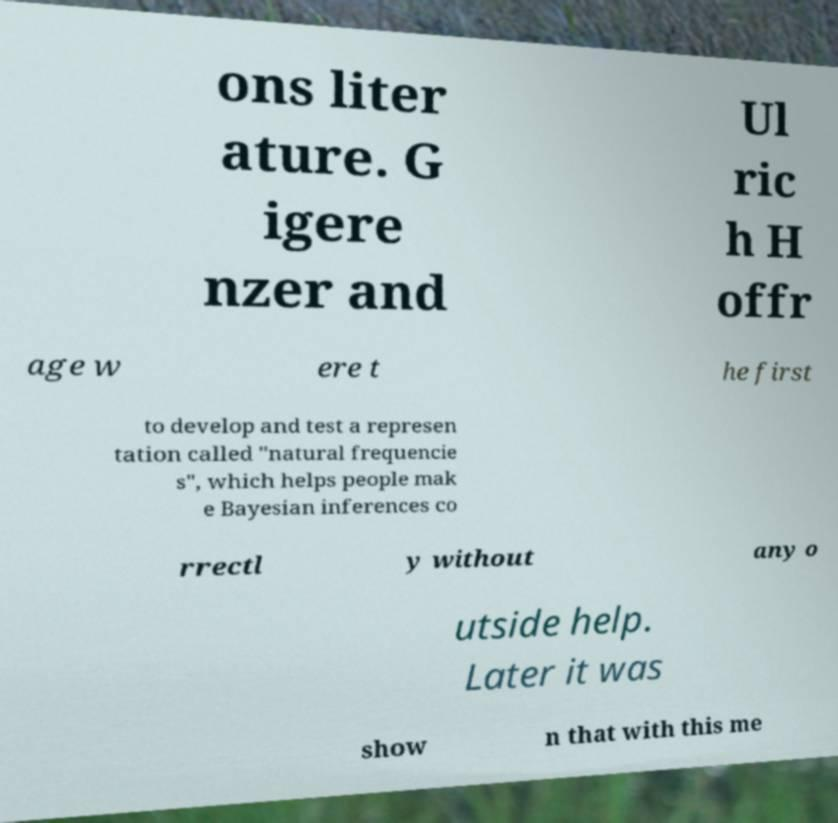Please identify and transcribe the text found in this image. ons liter ature. G igere nzer and Ul ric h H offr age w ere t he first to develop and test a represen tation called "natural frequencie s", which helps people mak e Bayesian inferences co rrectl y without any o utside help. Later it was show n that with this me 